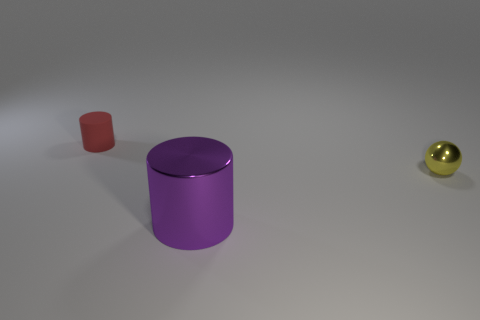Add 1 small green cylinders. How many objects exist? 4 Subtract all cylinders. How many objects are left? 1 Subtract 0 green cylinders. How many objects are left? 3 Subtract all big objects. Subtract all balls. How many objects are left? 1 Add 2 small objects. How many small objects are left? 4 Add 2 big cylinders. How many big cylinders exist? 3 